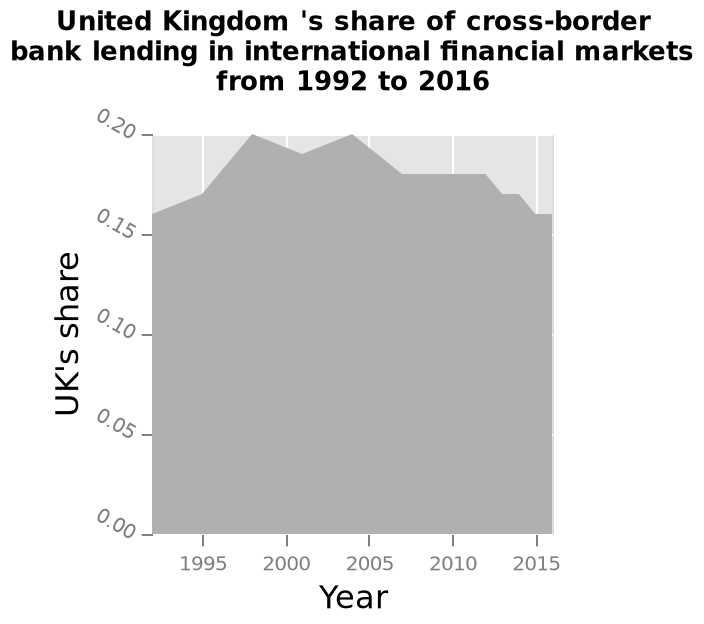<image>
What type of scale is used for the x-axis? The x-axis uses a linear scale from 1995 to 2015. Describe the following image in detail Here a area graph is named United Kingdom 's share of cross-border bank lending in international financial markets from 1992 to 2016. There is a linear scale from 1995 to 2015 on the x-axis, marked Year. A linear scale from 0.00 to 0.20 can be found along the y-axis, labeled UK's share. please summary the statistics and relations of the chart The Uk's share of cross-border bank lending in international financial markets from 1992 till 2016 saw two major peaks at 0.20 respectively between 1995 and 2000 and in around 2004 with a decrease just above 0.15 in 205. 